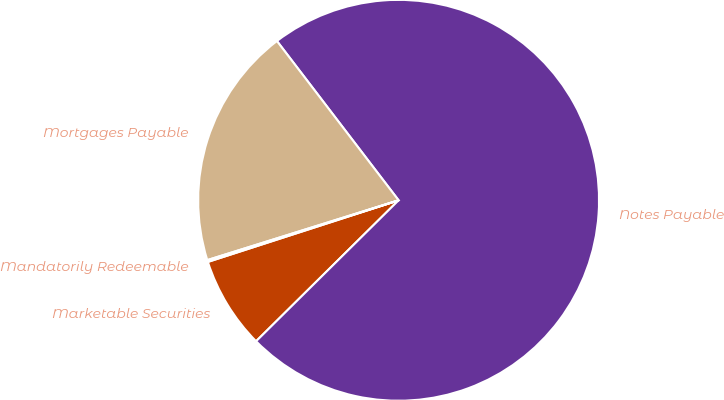Convert chart. <chart><loc_0><loc_0><loc_500><loc_500><pie_chart><fcel>Marketable Securities<fcel>Notes Payable<fcel>Mortgages Payable<fcel>Mandatorily Redeemable<nl><fcel>7.44%<fcel>72.97%<fcel>19.44%<fcel>0.15%<nl></chart> 